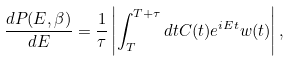<formula> <loc_0><loc_0><loc_500><loc_500>\frac { d P ( E , \beta ) } { d E } = \frac { 1 } { \tau } \left | \int _ { T } ^ { T + \tau } d t C ( t ) e ^ { i E t } w ( t ) \right | ,</formula> 